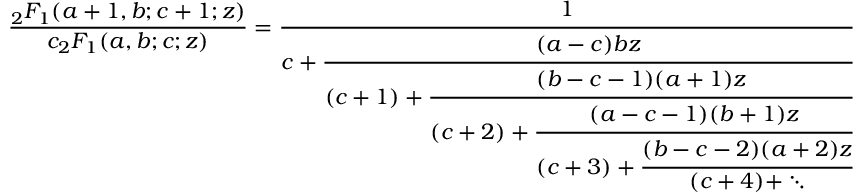Convert formula to latex. <formula><loc_0><loc_0><loc_500><loc_500>{ \frac { _ { 2 } F _ { 1 } ( a + 1 , b ; c + 1 ; z ) } { c _ { 2 } F _ { 1 } ( a , b ; c ; z ) } } = { \cfrac { 1 } { c + { \cfrac { ( a - c ) b z } { ( c + 1 ) + { \cfrac { ( b - c - 1 ) ( a + 1 ) z } { ( c + 2 ) + { \cfrac { ( a - c - 1 ) ( b + 1 ) z } { ( c + 3 ) + { \cfrac { ( b - c - 2 ) ( a + 2 ) z } { ( c + 4 ) + \ddots } } } } } } } } } }</formula> 